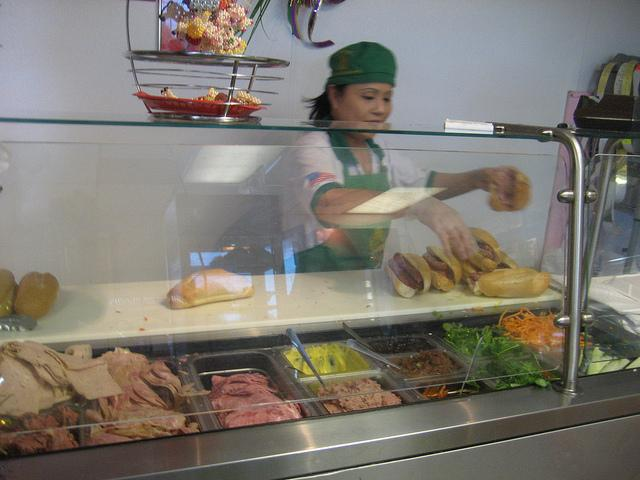What sort of specialty business is this? sandwich shop 